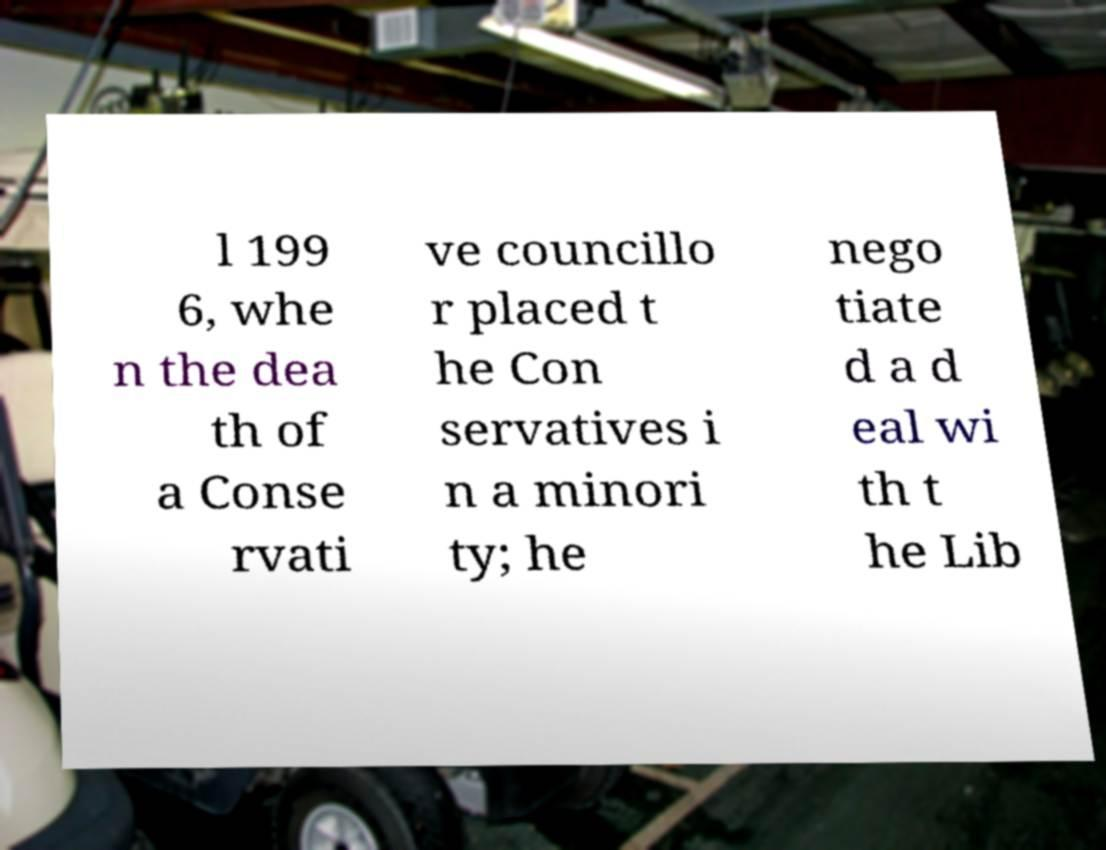Please read and relay the text visible in this image. What does it say? l 199 6, whe n the dea th of a Conse rvati ve councillo r placed t he Con servatives i n a minori ty; he nego tiate d a d eal wi th t he Lib 